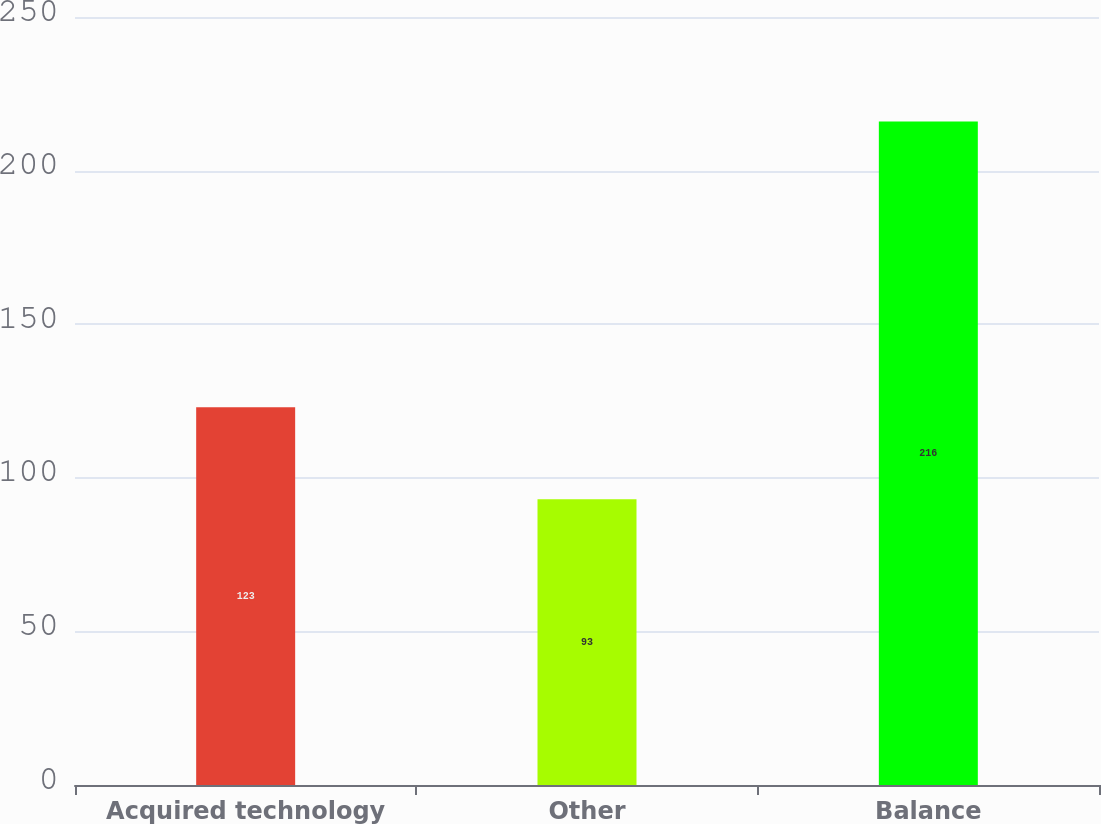Convert chart to OTSL. <chart><loc_0><loc_0><loc_500><loc_500><bar_chart><fcel>Acquired technology<fcel>Other<fcel>Balance<nl><fcel>123<fcel>93<fcel>216<nl></chart> 